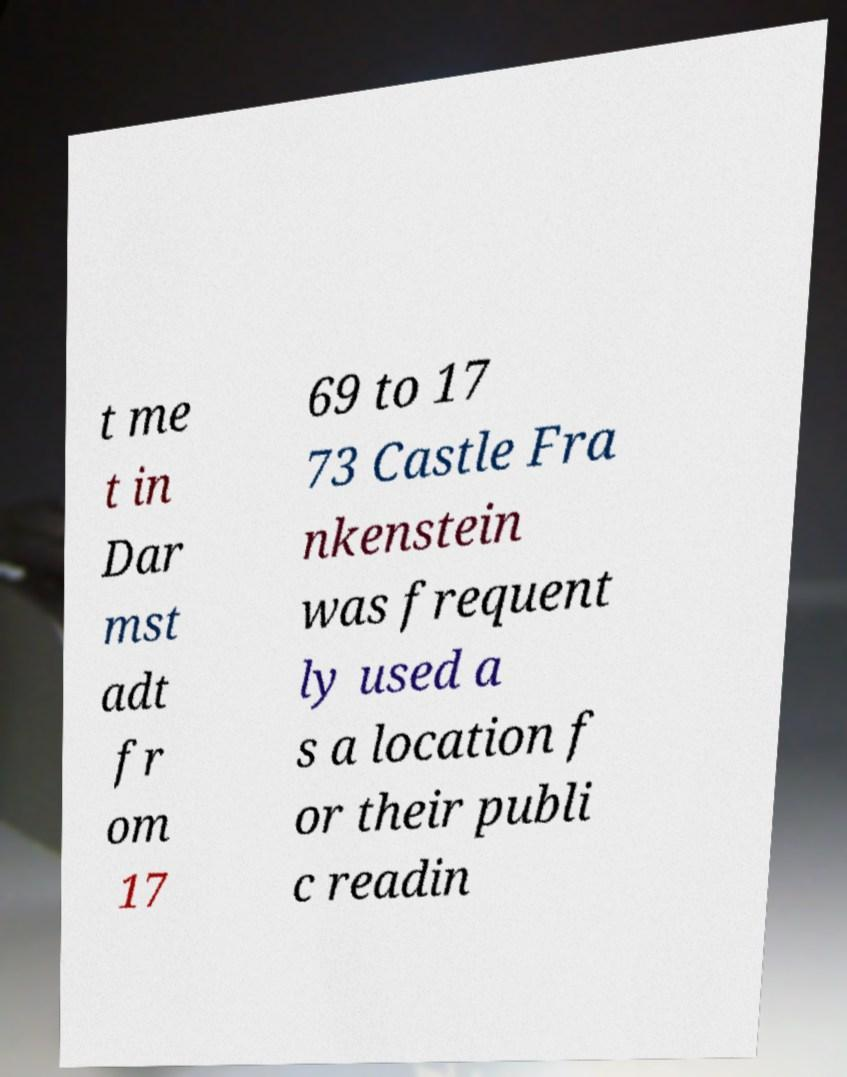I need the written content from this picture converted into text. Can you do that? t me t in Dar mst adt fr om 17 69 to 17 73 Castle Fra nkenstein was frequent ly used a s a location f or their publi c readin 